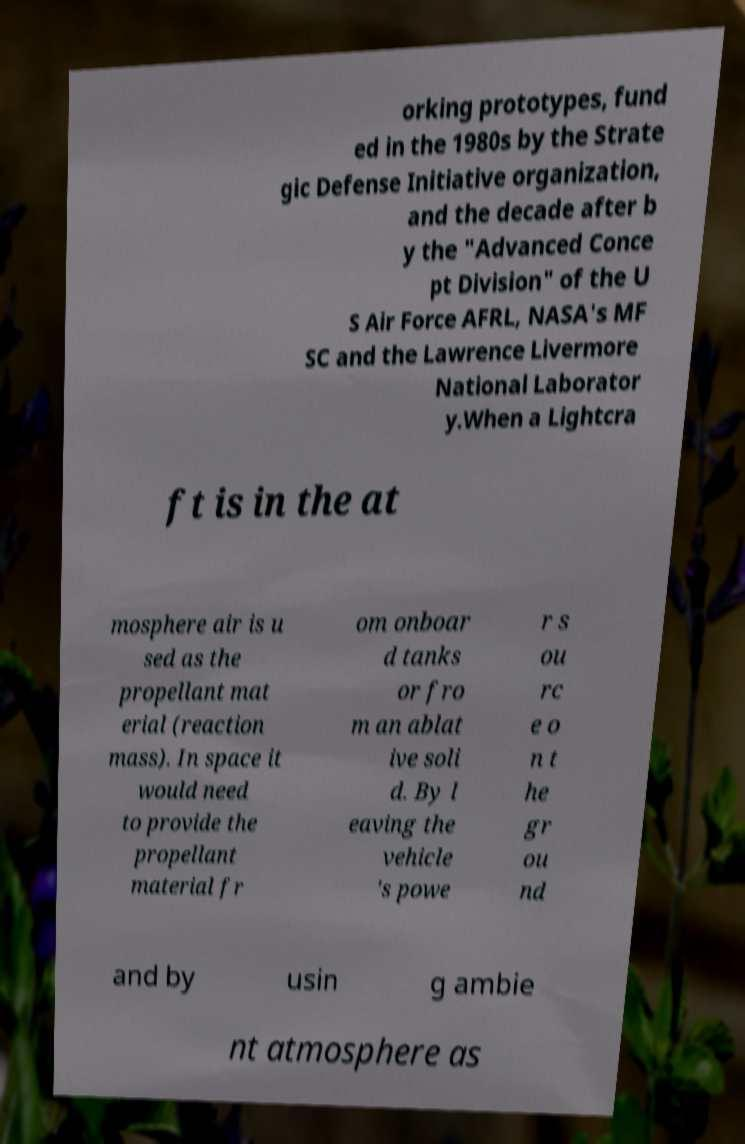For documentation purposes, I need the text within this image transcribed. Could you provide that? orking prototypes, fund ed in the 1980s by the Strate gic Defense Initiative organization, and the decade after b y the "Advanced Conce pt Division" of the U S Air Force AFRL, NASA's MF SC and the Lawrence Livermore National Laborator y.When a Lightcra ft is in the at mosphere air is u sed as the propellant mat erial (reaction mass). In space it would need to provide the propellant material fr om onboar d tanks or fro m an ablat ive soli d. By l eaving the vehicle 's powe r s ou rc e o n t he gr ou nd and by usin g ambie nt atmosphere as 